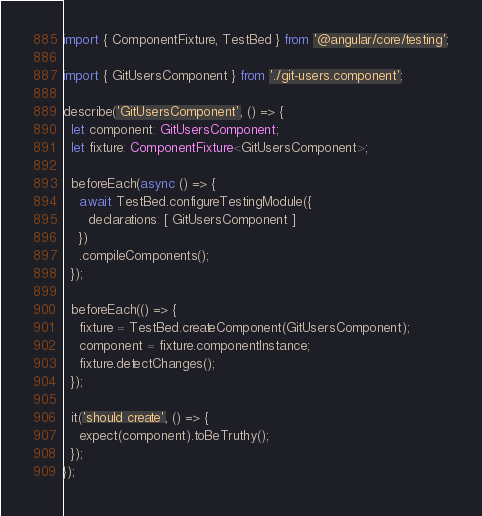Convert code to text. <code><loc_0><loc_0><loc_500><loc_500><_TypeScript_>import { ComponentFixture, TestBed } from '@angular/core/testing';

import { GitUsersComponent } from './git-users.component';

describe('GitUsersComponent', () => {
  let component: GitUsersComponent;
  let fixture: ComponentFixture<GitUsersComponent>;

  beforeEach(async () => {
    await TestBed.configureTestingModule({
      declarations: [ GitUsersComponent ]
    })
    .compileComponents();
  });

  beforeEach(() => {
    fixture = TestBed.createComponent(GitUsersComponent);
    component = fixture.componentInstance;
    fixture.detectChanges();
  });

  it('should create', () => {
    expect(component).toBeTruthy();
  });
});
</code> 